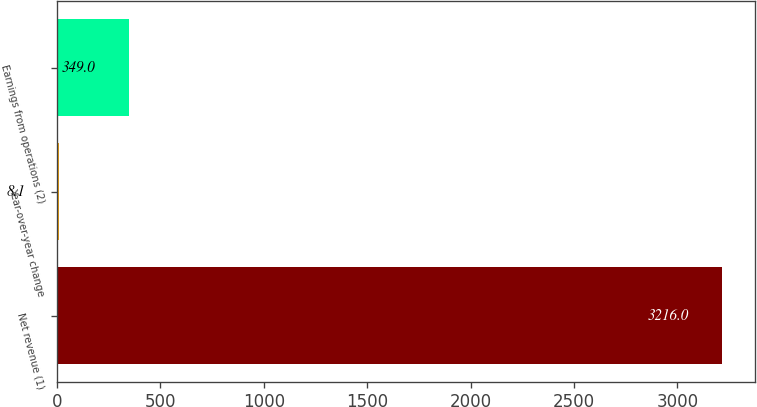Convert chart to OTSL. <chart><loc_0><loc_0><loc_500><loc_500><bar_chart><fcel>Net revenue (1)<fcel>Year-over-year change<fcel>Earnings from operations (2)<nl><fcel>3216<fcel>8.1<fcel>349<nl></chart> 